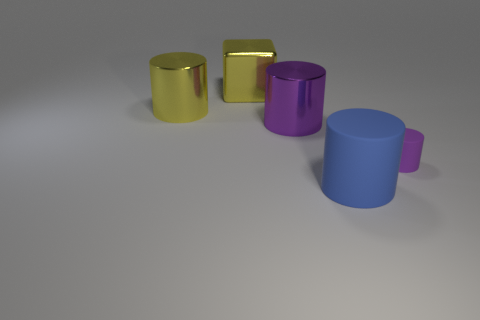Subtract all cyan cylinders. Subtract all red spheres. How many cylinders are left? 4 Subtract all cyan spheres. How many brown cylinders are left? 0 Add 5 tiny browns. How many large yellows exist? 0 Subtract all big blue things. Subtract all big metallic spheres. How many objects are left? 4 Add 3 tiny cylinders. How many tiny cylinders are left? 4 Add 1 small purple objects. How many small purple objects exist? 2 Add 2 large yellow metallic blocks. How many objects exist? 7 Subtract all yellow cylinders. How many cylinders are left? 3 Subtract all big blue cylinders. How many cylinders are left? 3 Subtract 0 red cylinders. How many objects are left? 5 